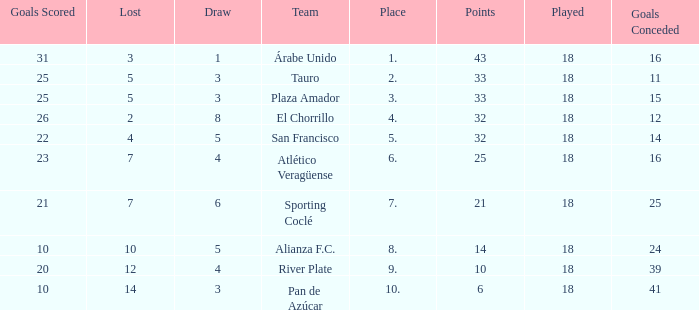How many points did the team have that conceded 41 goals and finish in a place larger than 10? 0.0. 